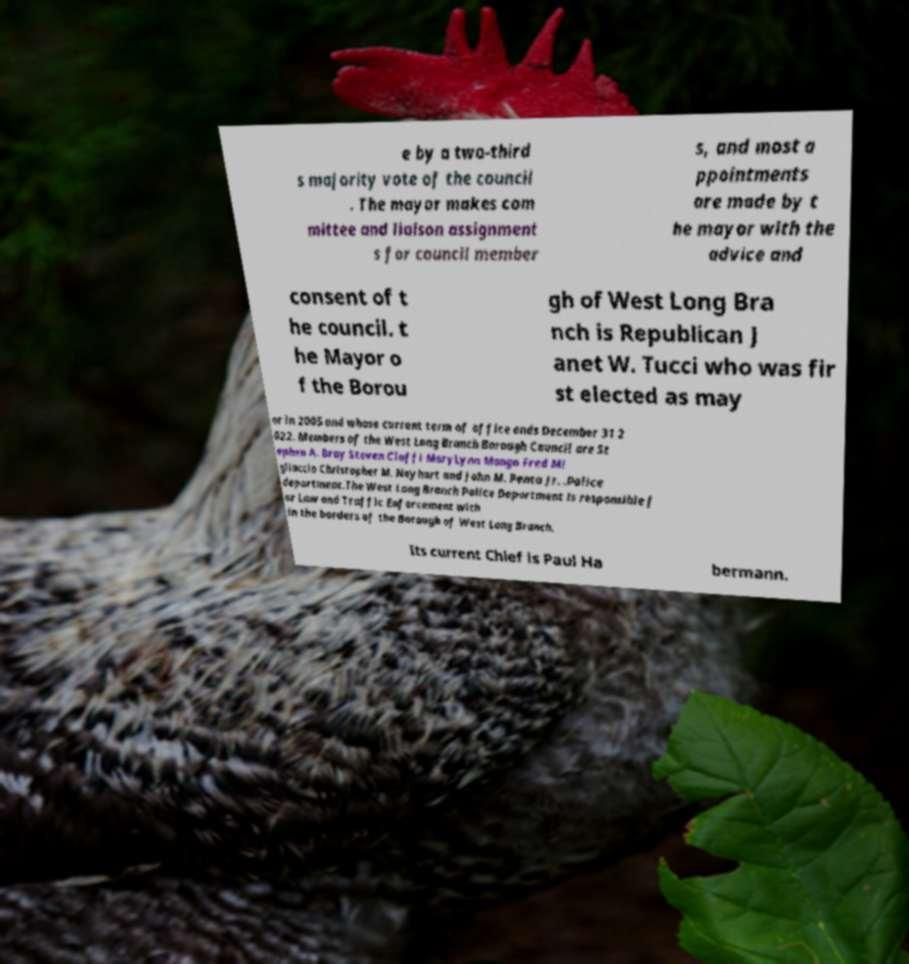What messages or text are displayed in this image? I need them in a readable, typed format. e by a two-third s majority vote of the council . The mayor makes com mittee and liaison assignment s for council member s, and most a ppointments are made by t he mayor with the advice and consent of t he council. t he Mayor o f the Borou gh of West Long Bra nch is Republican J anet W. Tucci who was fir st elected as may or in 2005 and whose current term of office ends December 31 2 022. Members of the West Long Branch Borough Council are St ephen A. Bray Steven Cioffi MaryLynn Mango Fred Mi gliaccio Christopher M. Neyhart and John M. Penta Jr. .Police department.The West Long Branch Police Department is responsible f or Law and Traffic Enforcement with in the borders of the Borough of West Long Branch. Its current Chief is Paul Ha bermann. 